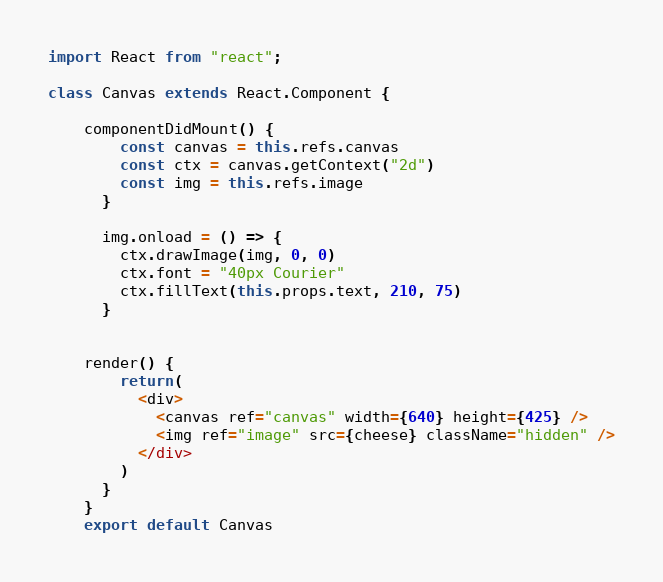<code> <loc_0><loc_0><loc_500><loc_500><_JavaScript_>import React from "react";

class Canvas extends React.Component {

    componentDidMount() {
        const canvas = this.refs.canvas
        const ctx = canvas.getContext("2d")
        const img = this.refs.image
      }

      img.onload = () => {
        ctx.drawImage(img, 0, 0)
        ctx.font = "40px Courier"
        ctx.fillText(this.props.text, 210, 75)
      }
    
    
    render() {
        return(
          <div>
            <canvas ref="canvas" width={640} height={425} />
            <img ref="image" src={cheese} className="hidden" />
          </div>
        )
      }
    }
    export default Canvas</code> 